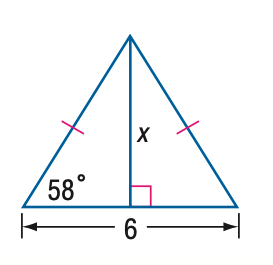Answer the mathemtical geometry problem and directly provide the correct option letter.
Question: Find x. Round to the nearest tenth.
Choices: A: 3.7 B: 4.8 C: 5.1 D: 6.0 B 